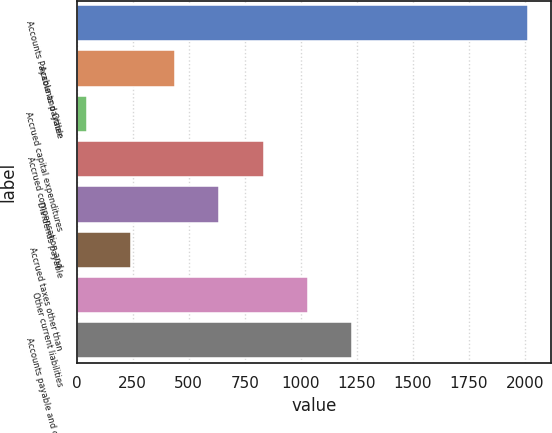Convert chart. <chart><loc_0><loc_0><loc_500><loc_500><bar_chart><fcel>Accounts Payable and Other<fcel>Accounts payable<fcel>Accrued capital expenditures<fcel>Accrued compensation and<fcel>Dividends payable<fcel>Accrued taxes other than<fcel>Other current liabilities<fcel>Accounts payable and other<nl><fcel>2015<fcel>439.8<fcel>46<fcel>833.6<fcel>636.7<fcel>242.9<fcel>1030.5<fcel>1227.4<nl></chart> 